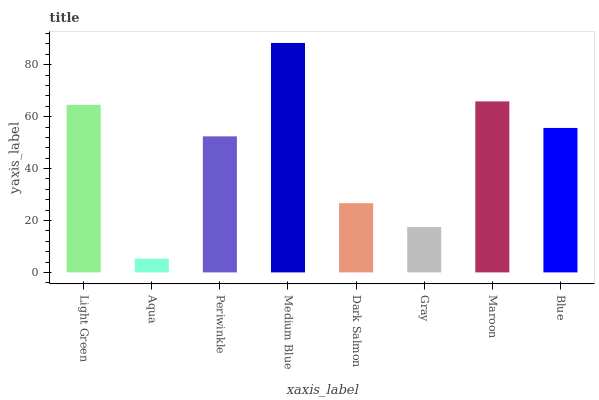Is Aqua the minimum?
Answer yes or no. Yes. Is Medium Blue the maximum?
Answer yes or no. Yes. Is Periwinkle the minimum?
Answer yes or no. No. Is Periwinkle the maximum?
Answer yes or no. No. Is Periwinkle greater than Aqua?
Answer yes or no. Yes. Is Aqua less than Periwinkle?
Answer yes or no. Yes. Is Aqua greater than Periwinkle?
Answer yes or no. No. Is Periwinkle less than Aqua?
Answer yes or no. No. Is Blue the high median?
Answer yes or no. Yes. Is Periwinkle the low median?
Answer yes or no. Yes. Is Light Green the high median?
Answer yes or no. No. Is Gray the low median?
Answer yes or no. No. 